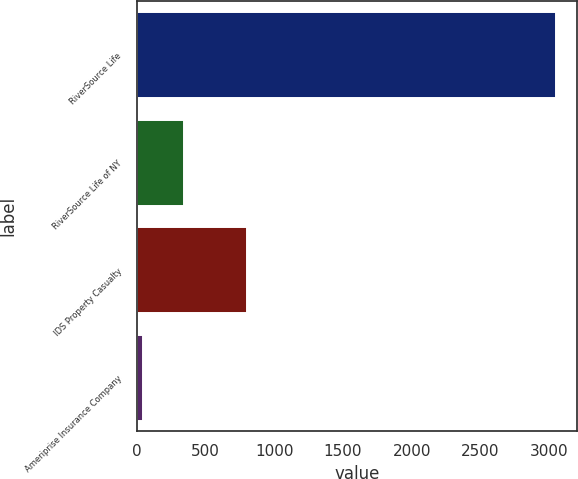<chart> <loc_0><loc_0><loc_500><loc_500><bar_chart><fcel>RiverSource Life<fcel>RiverSource Life of NY<fcel>IDS Property Casualty<fcel>Ameriprise Insurance Company<nl><fcel>3052<fcel>347.5<fcel>800<fcel>47<nl></chart> 